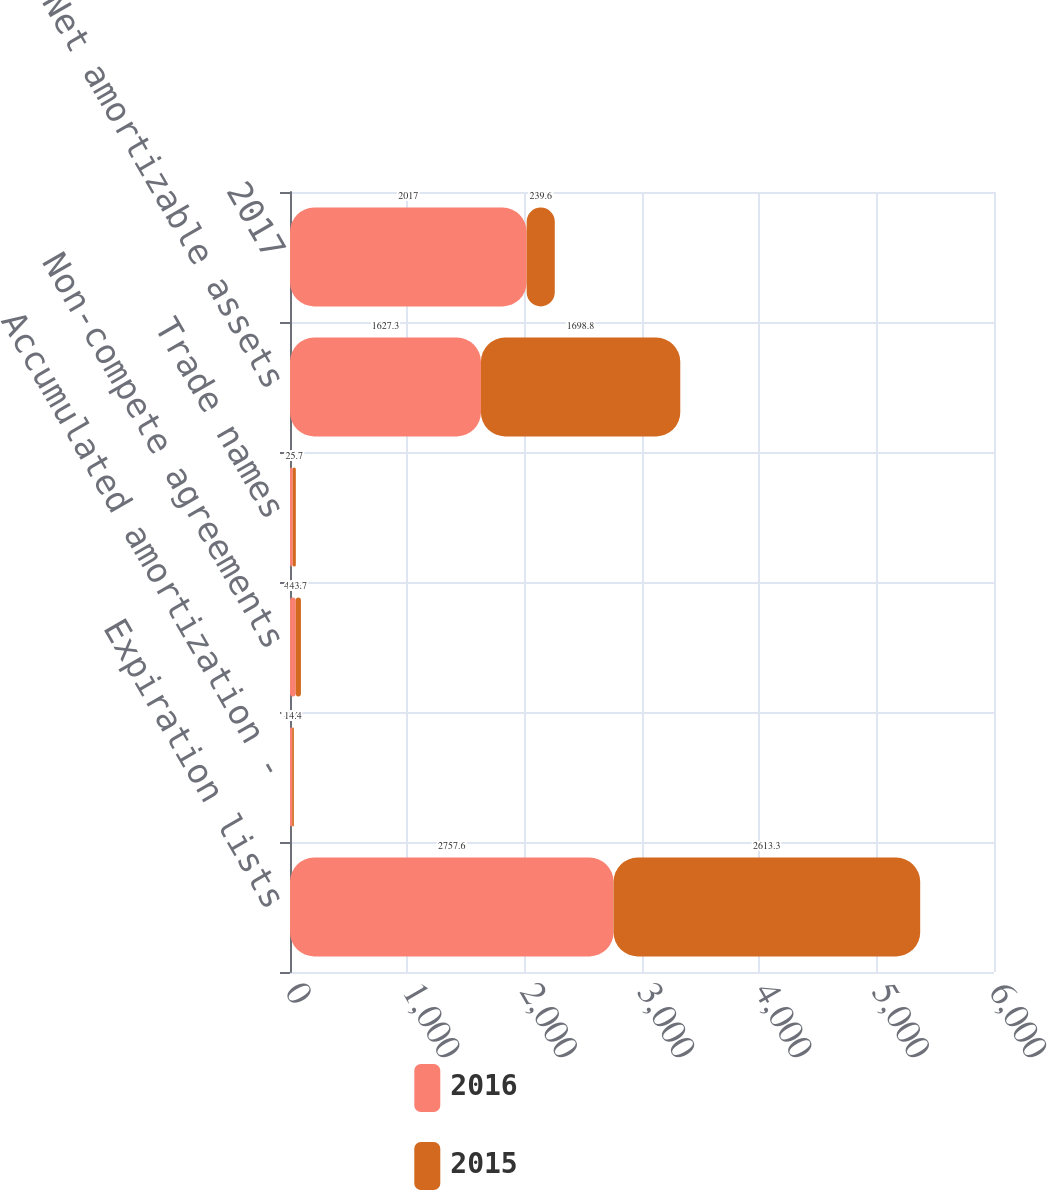<chart> <loc_0><loc_0><loc_500><loc_500><stacked_bar_chart><ecel><fcel>Expiration lists<fcel>Accumulated amortization -<fcel>Non-compete agreements<fcel>Trade names<fcel>Net amortizable assets<fcel>2017<nl><fcel>2016<fcel>2757.6<fcel>18.5<fcel>49.3<fcel>24<fcel>1627.3<fcel>2017<nl><fcel>2015<fcel>2613.3<fcel>14.4<fcel>43.7<fcel>25.7<fcel>1698.8<fcel>239.6<nl></chart> 